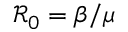<formula> <loc_0><loc_0><loc_500><loc_500>\mathcal { R } _ { 0 } = \beta / \mu</formula> 